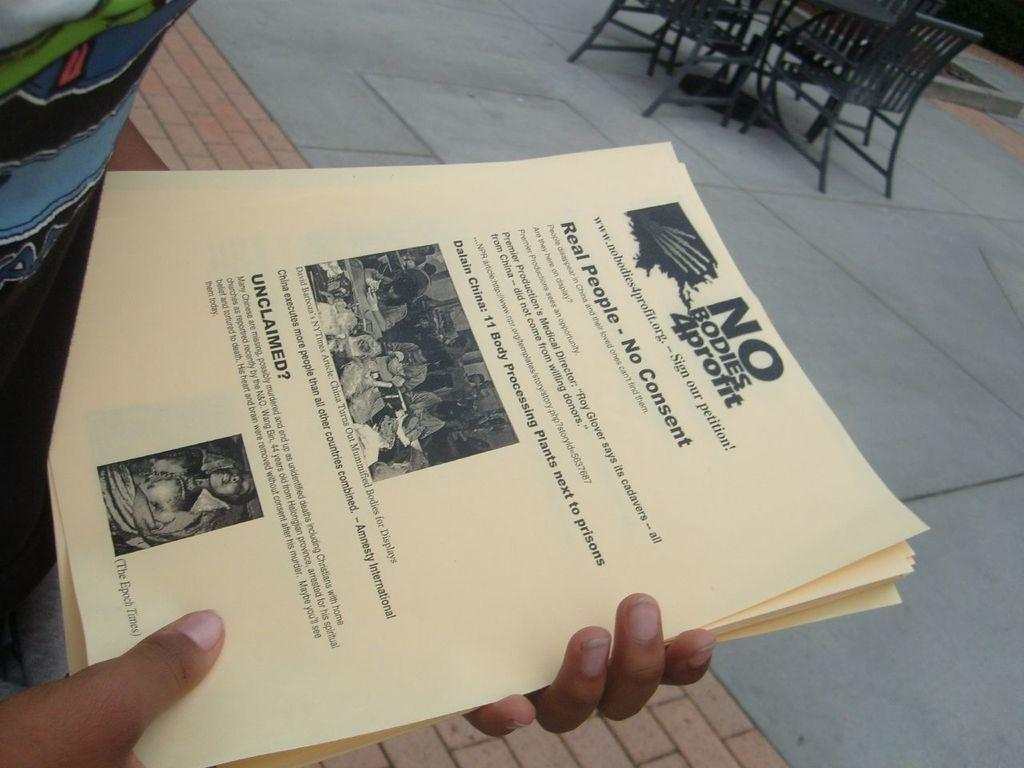<image>
Offer a succinct explanation of the picture presented. A person holds alot of pamphlets starting with the word NO. 